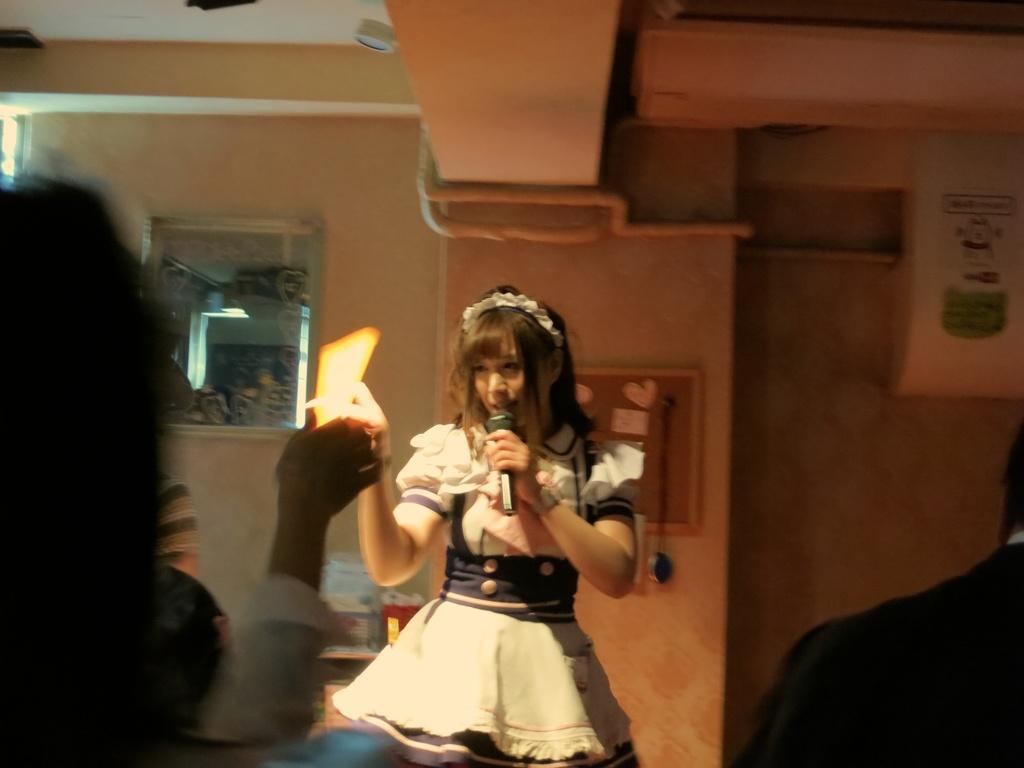Could you give a brief overview of what you see in this image? In this picture there is a woman standing and holding the microphone and object. In the foreground there are two people. At the back there is a mirror and there is a poster on the wall. At the top there are pipes and there is a light. At the bottom there are objects on the table. 